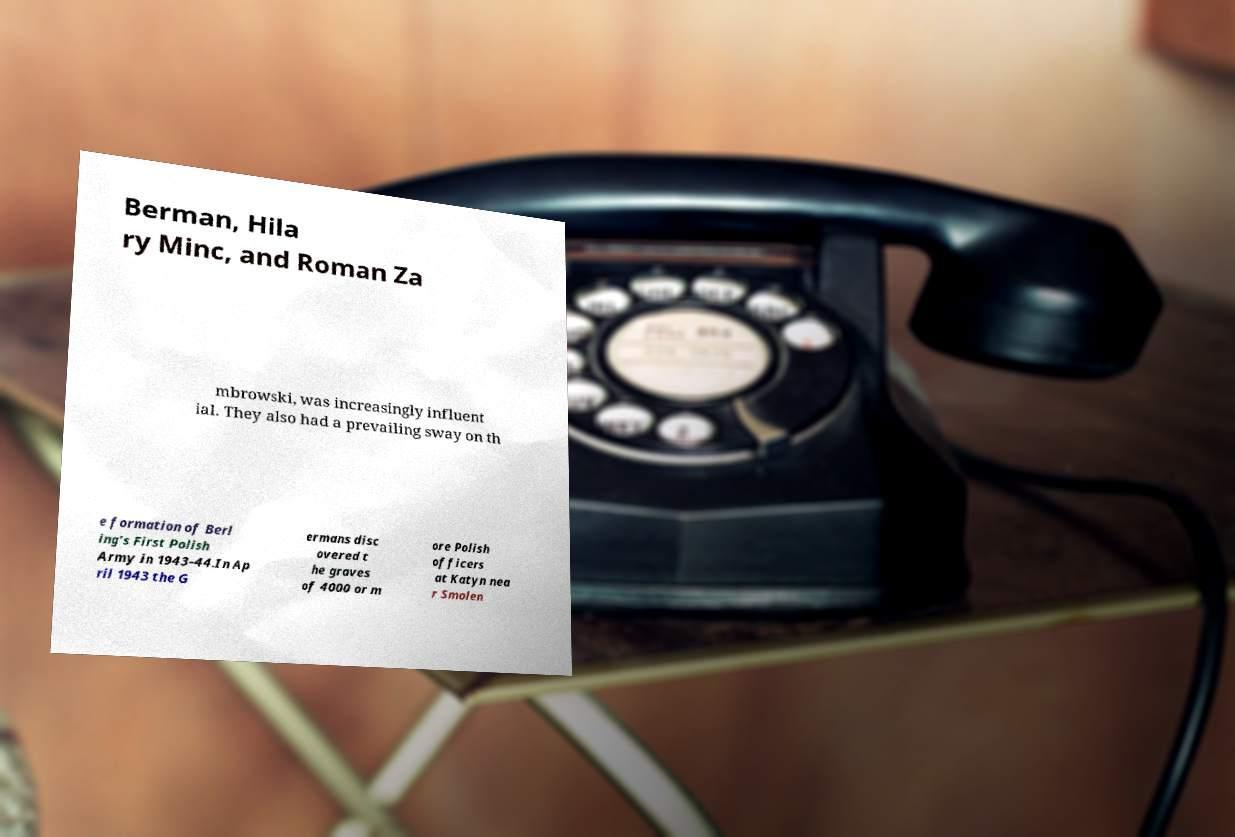Can you read and provide the text displayed in the image?This photo seems to have some interesting text. Can you extract and type it out for me? Berman, Hila ry Minc, and Roman Za mbrowski, was increasingly influent ial. They also had a prevailing sway on th e formation of Berl ing's First Polish Army in 1943–44.In Ap ril 1943 the G ermans disc overed t he graves of 4000 or m ore Polish officers at Katyn nea r Smolen 